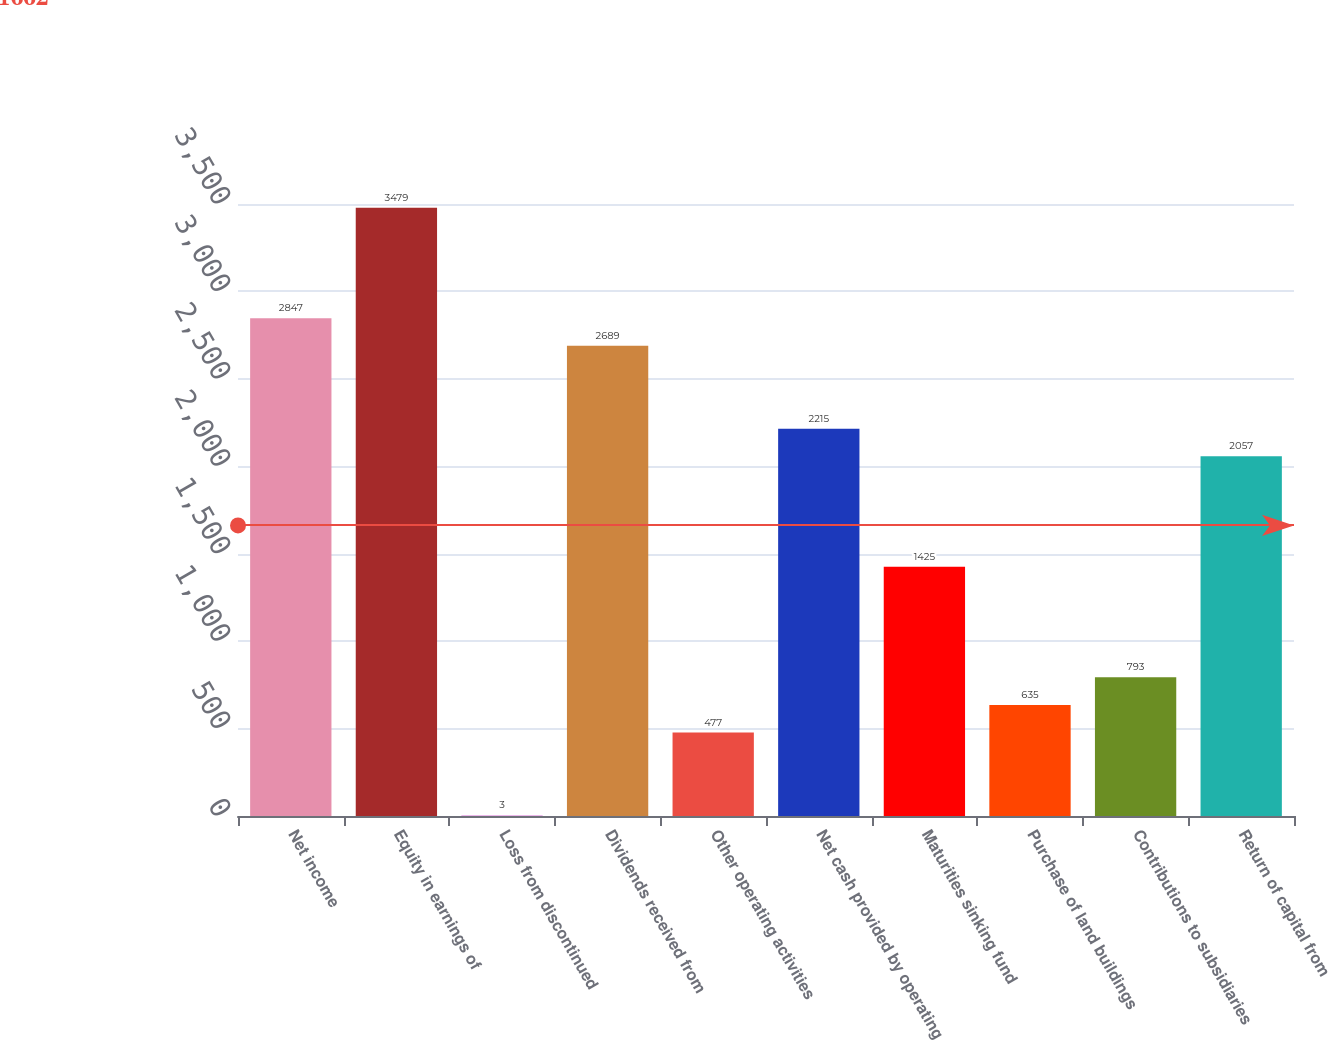Convert chart. <chart><loc_0><loc_0><loc_500><loc_500><bar_chart><fcel>Net income<fcel>Equity in earnings of<fcel>Loss from discontinued<fcel>Dividends received from<fcel>Other operating activities<fcel>Net cash provided by operating<fcel>Maturities sinking fund<fcel>Purchase of land buildings<fcel>Contributions to subsidiaries<fcel>Return of capital from<nl><fcel>2847<fcel>3479<fcel>3<fcel>2689<fcel>477<fcel>2215<fcel>1425<fcel>635<fcel>793<fcel>2057<nl></chart> 